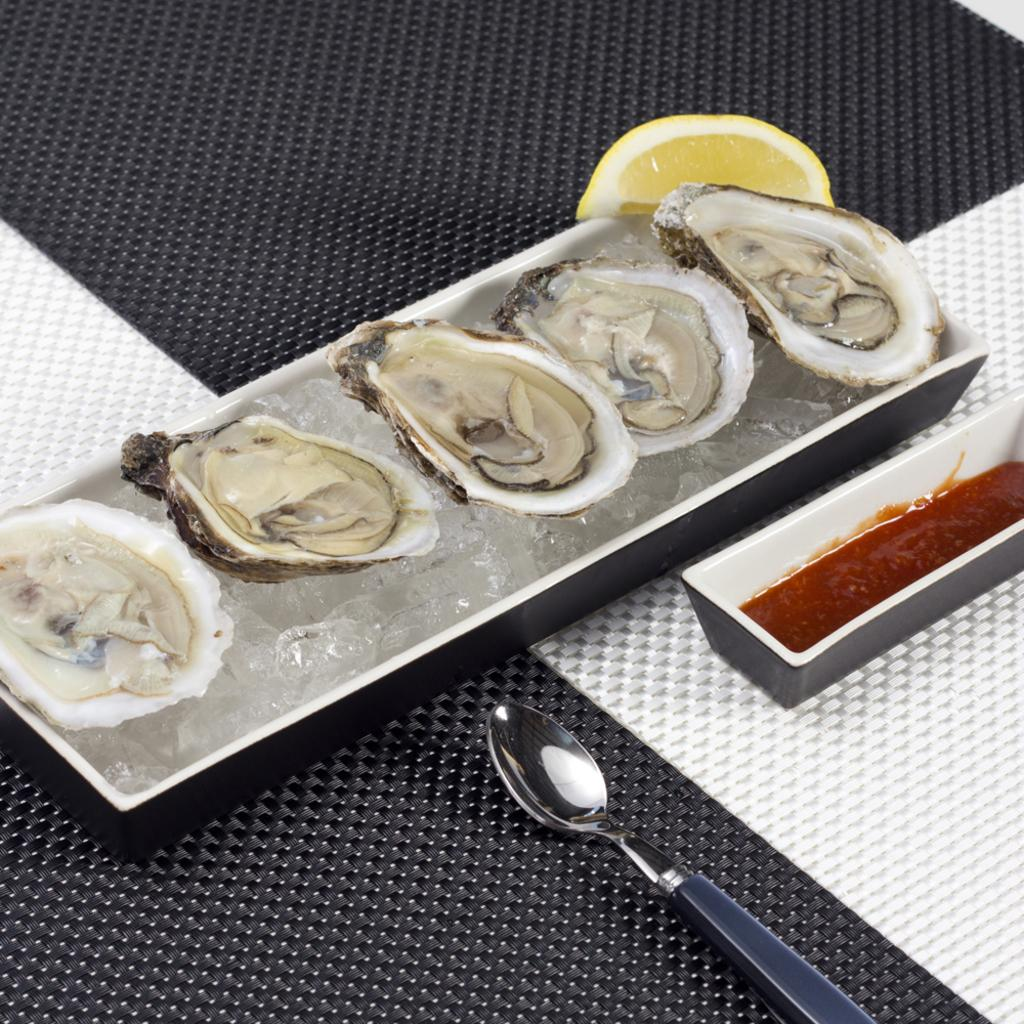What is in the ice tray that is visible in the image? There is food in the ice tray in the image. What type of fruit can be seen in the image? There is a lemon piece in the image. Where is the sauce bowl located in the image? The sauce bowl is on the right side in the image. What utensil is visible in the image? There is a spoon visible in the image. What might be used to cover or protect the table in the image? There appears to be a cloth on the table in the image. What type of fuel is being used to power the lemon in the image? There is no fuel present in the image, and the lemon is not being used as a power source. What song is being played in the background of the image? There is no indication of any music or song being played in the image. 